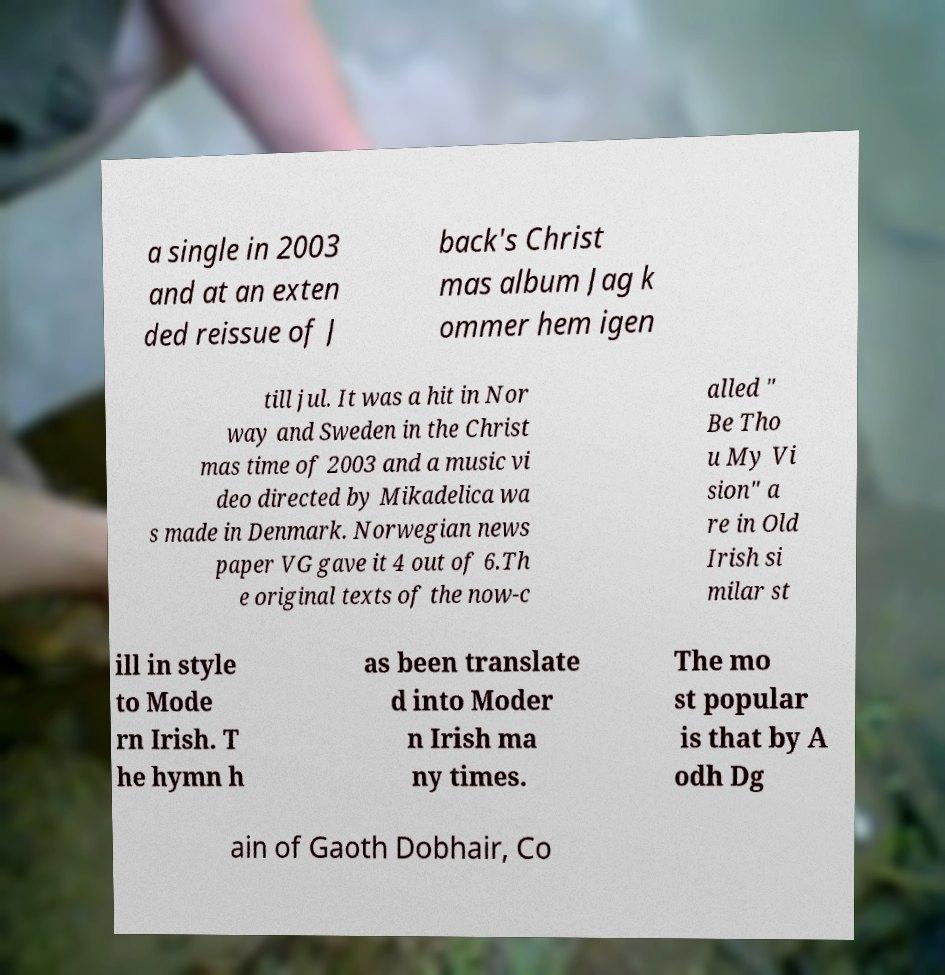I need the written content from this picture converted into text. Can you do that? a single in 2003 and at an exten ded reissue of J back's Christ mas album Jag k ommer hem igen till jul. It was a hit in Nor way and Sweden in the Christ mas time of 2003 and a music vi deo directed by Mikadelica wa s made in Denmark. Norwegian news paper VG gave it 4 out of 6.Th e original texts of the now-c alled " Be Tho u My Vi sion" a re in Old Irish si milar st ill in style to Mode rn Irish. T he hymn h as been translate d into Moder n Irish ma ny times. The mo st popular is that by A odh Dg ain of Gaoth Dobhair, Co 